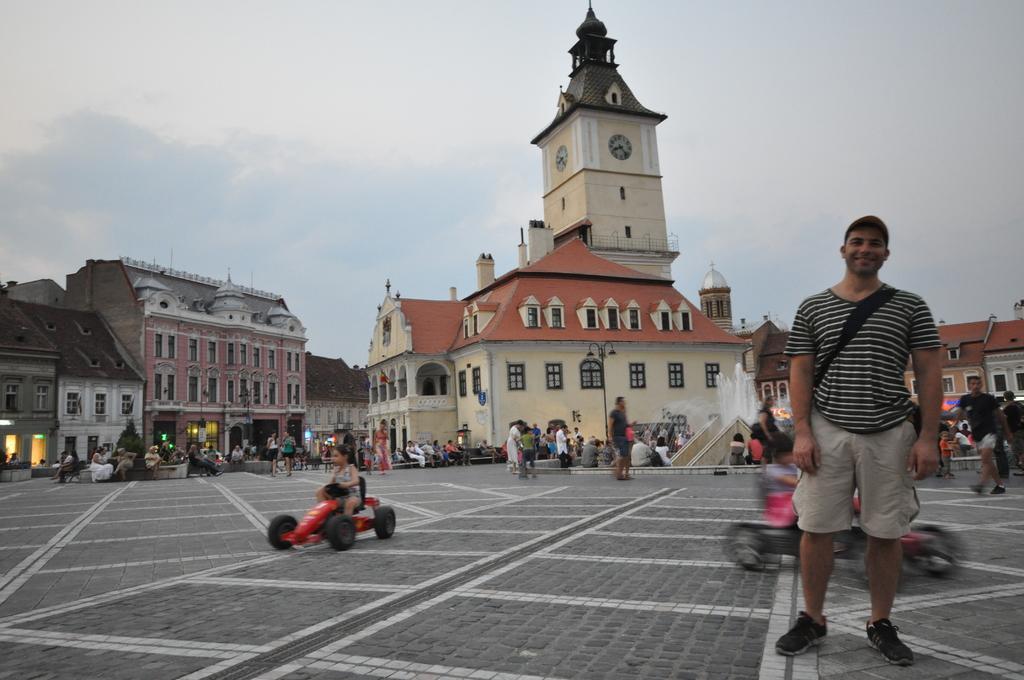How would you summarize this image in a sentence or two? On the right side of the image, we can see a person is standing and smiling. In the background, we can see people, buildings, walls, windows, street lights, water fountain, chairs and sky. We can see kids are riding vehicles. In the middle of the image, we can see a tower with clocks. 